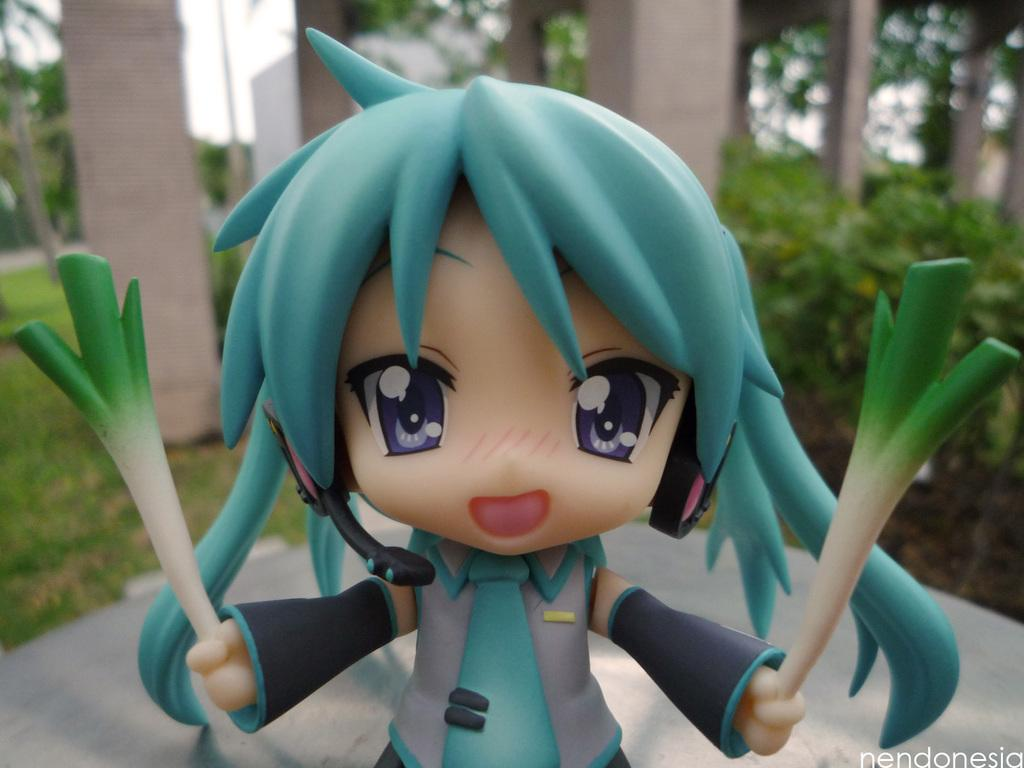What is the main subject in the center of the image? There is a doll in the center of the image. What can be seen in the background of the image? There are trees and a building in the background of the image. How many pages are visible in the image? There are no pages present in the image. What type of straw is being used by the doll in the image? There is no straw present in the image, and the doll is not shown using any object. 